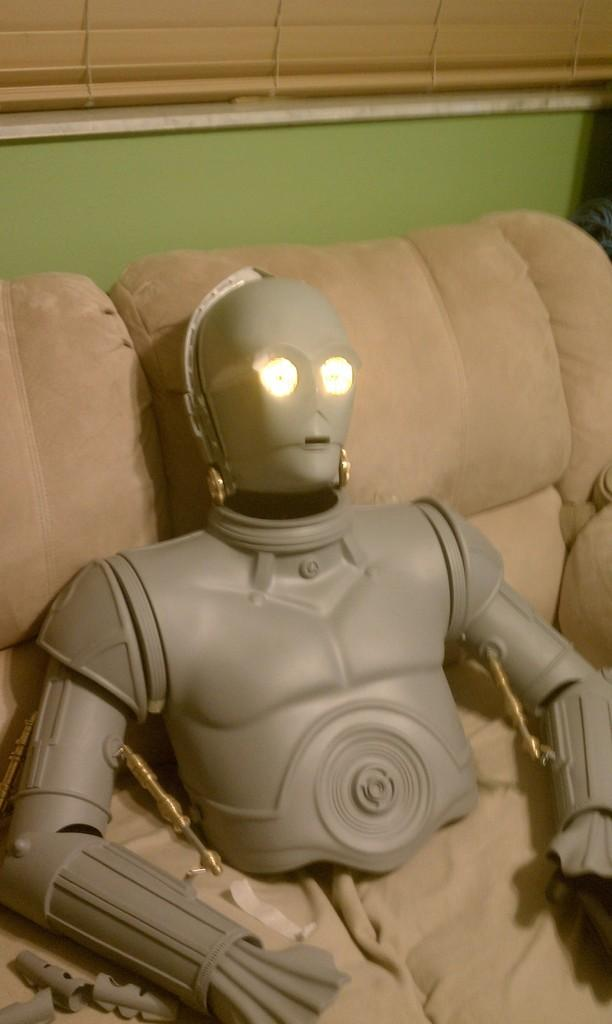What object can be seen in the image? There is a toy in the image. Where is the toy located? The toy is on a sofa. What type of zinc is present in the image? There is no zinc present in the image; it features a toy on a sofa. Can you see a house in the image? There is no house visible in the image; it only a toy on a sofa is present. 